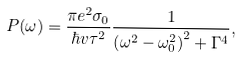Convert formula to latex. <formula><loc_0><loc_0><loc_500><loc_500>P ( \omega ) = \frac { \pi e ^ { 2 } \sigma _ { 0 } } { \hbar { v } \tau ^ { 2 } } \frac { 1 } { \left ( \omega ^ { 2 } - \omega _ { 0 } ^ { 2 } \right ) ^ { 2 } + \Gamma ^ { 4 } } ,</formula> 